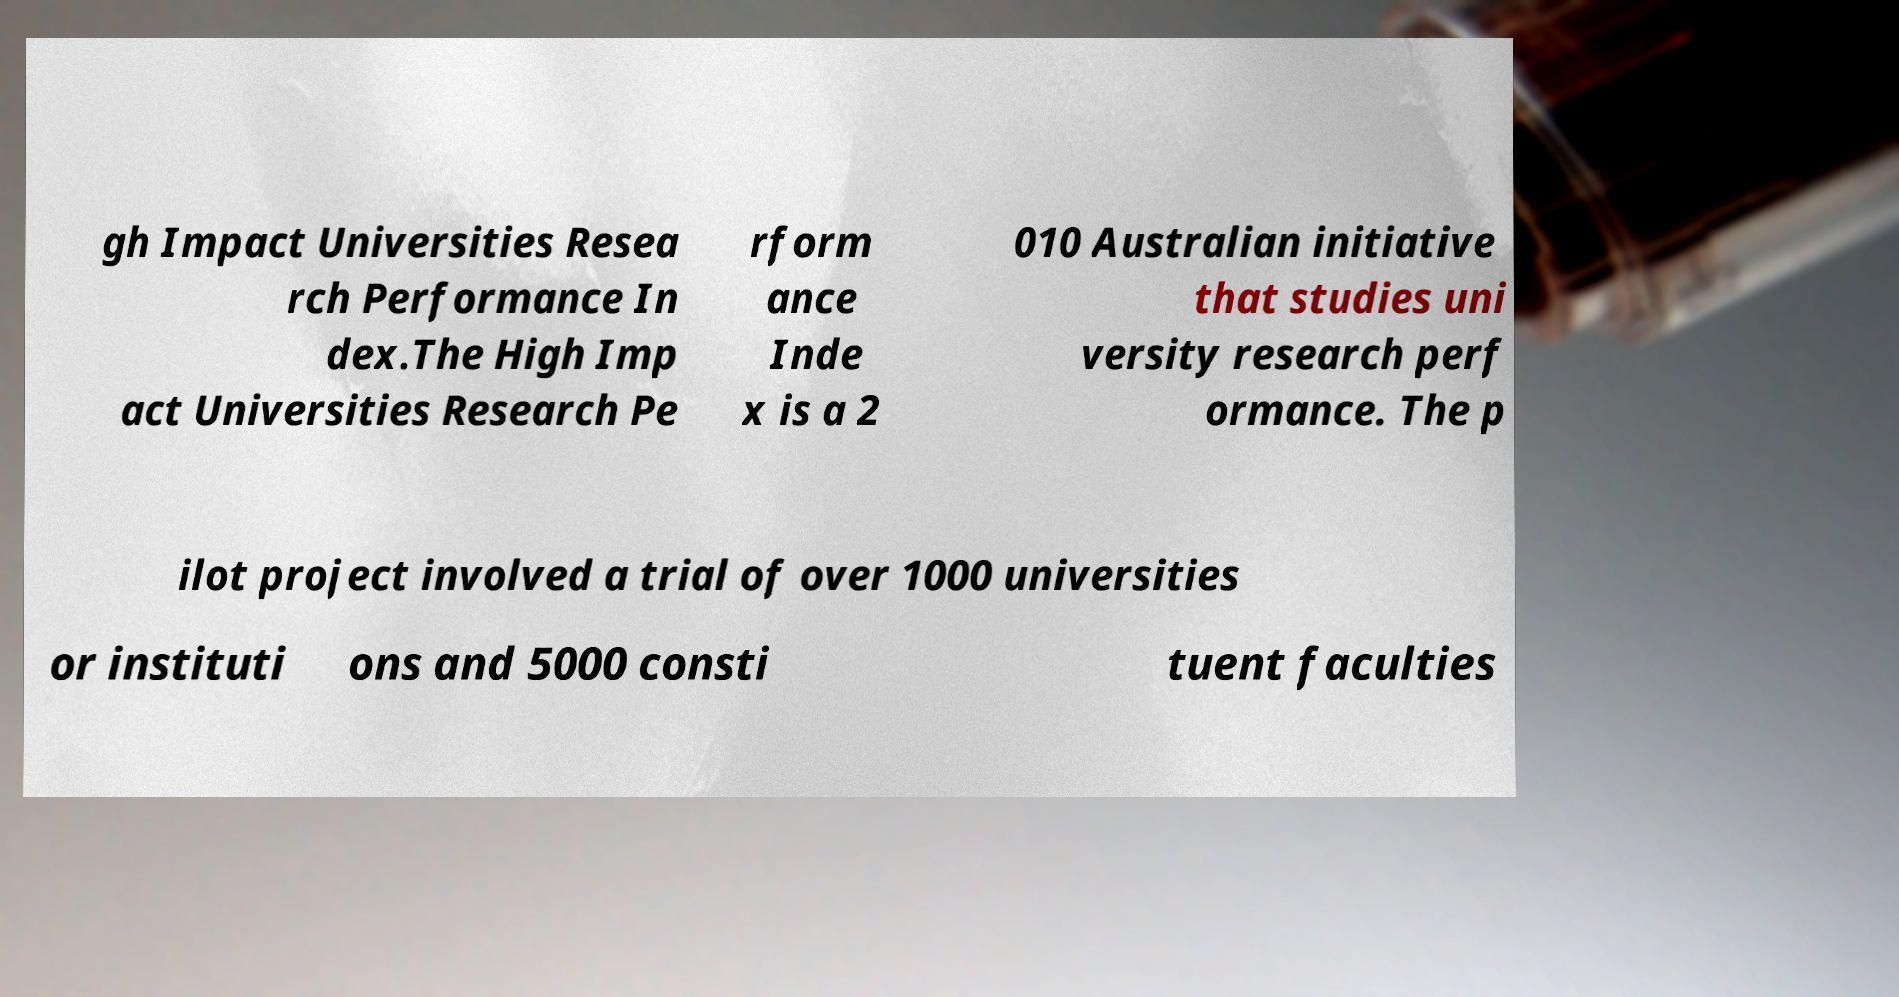Could you extract and type out the text from this image? gh Impact Universities Resea rch Performance In dex.The High Imp act Universities Research Pe rform ance Inde x is a 2 010 Australian initiative that studies uni versity research perf ormance. The p ilot project involved a trial of over 1000 universities or instituti ons and 5000 consti tuent faculties 